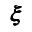<formula> <loc_0><loc_0><loc_500><loc_500>{ \pm b \xi }</formula> 